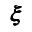<formula> <loc_0><loc_0><loc_500><loc_500>{ \pm b \xi }</formula> 